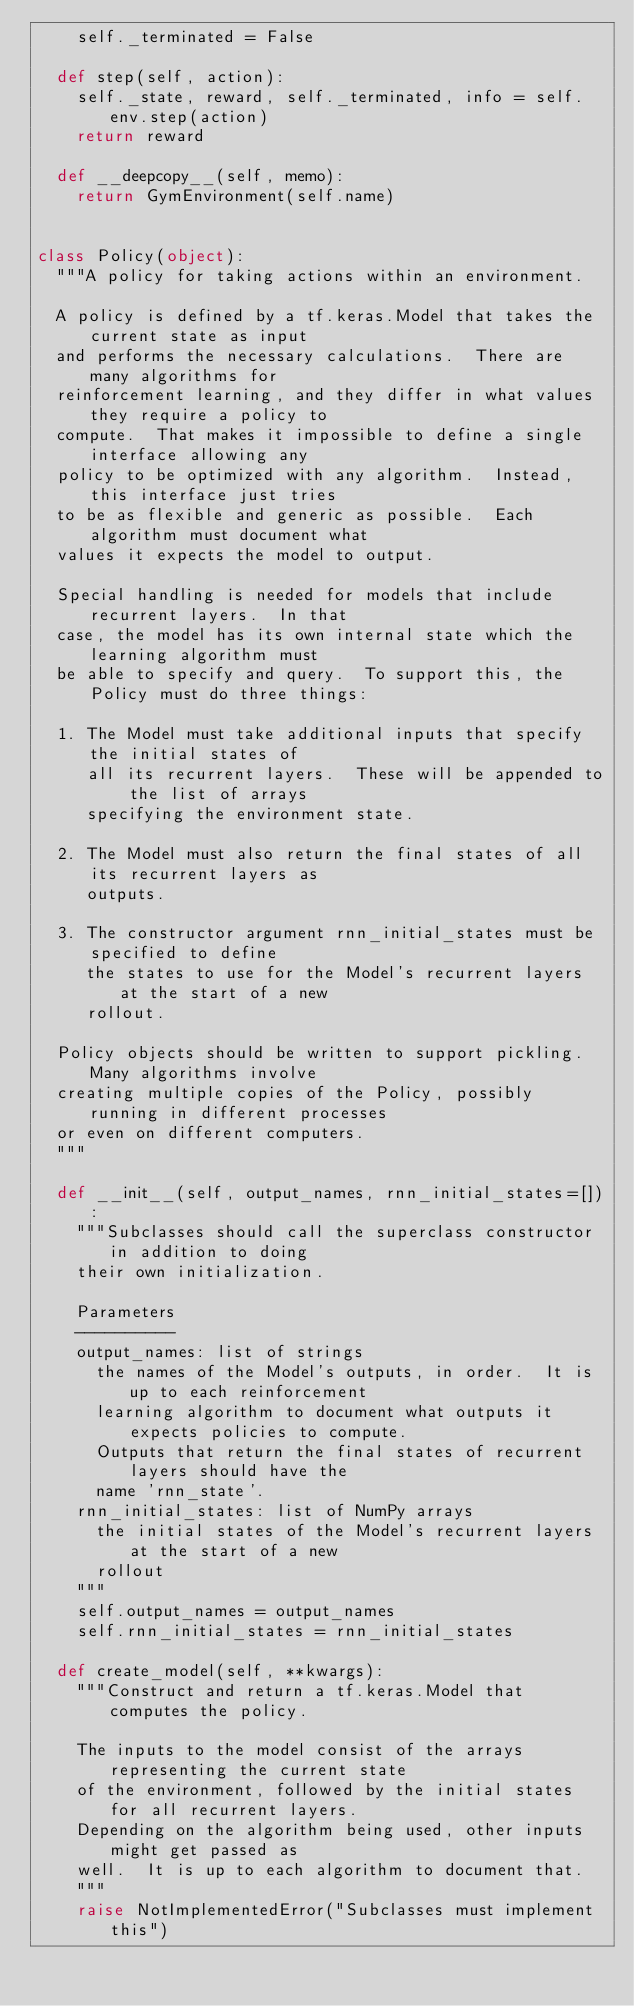Convert code to text. <code><loc_0><loc_0><loc_500><loc_500><_Python_>    self._terminated = False

  def step(self, action):
    self._state, reward, self._terminated, info = self.env.step(action)
    return reward

  def __deepcopy__(self, memo):
    return GymEnvironment(self.name)


class Policy(object):
  """A policy for taking actions within an environment.

  A policy is defined by a tf.keras.Model that takes the current state as input
  and performs the necessary calculations.  There are many algorithms for
  reinforcement learning, and they differ in what values they require a policy to
  compute.  That makes it impossible to define a single interface allowing any
  policy to be optimized with any algorithm.  Instead, this interface just tries
  to be as flexible and generic as possible.  Each algorithm must document what
  values it expects the model to output.

  Special handling is needed for models that include recurrent layers.  In that
  case, the model has its own internal state which the learning algorithm must
  be able to specify and query.  To support this, the Policy must do three things:

  1. The Model must take additional inputs that specify the initial states of
     all its recurrent layers.  These will be appended to the list of arrays
     specifying the environment state.

  2. The Model must also return the final states of all its recurrent layers as
     outputs.

  3. The constructor argument rnn_initial_states must be specified to define
     the states to use for the Model's recurrent layers at the start of a new
     rollout.

  Policy objects should be written to support pickling.  Many algorithms involve
  creating multiple copies of the Policy, possibly running in different processes
  or even on different computers.
  """

  def __init__(self, output_names, rnn_initial_states=[]):
    """Subclasses should call the superclass constructor in addition to doing
    their own initialization.

    Parameters
    ----------
    output_names: list of strings
      the names of the Model's outputs, in order.  It is up to each reinforcement
      learning algorithm to document what outputs it expects policies to compute.
      Outputs that return the final states of recurrent layers should have the
      name 'rnn_state'.
    rnn_initial_states: list of NumPy arrays
      the initial states of the Model's recurrent layers at the start of a new
      rollout
    """
    self.output_names = output_names
    self.rnn_initial_states = rnn_initial_states

  def create_model(self, **kwargs):
    """Construct and return a tf.keras.Model that computes the policy.

    The inputs to the model consist of the arrays representing the current state
    of the environment, followed by the initial states for all recurrent layers.
    Depending on the algorithm being used, other inputs might get passed as
    well.  It is up to each algorithm to document that.
    """
    raise NotImplementedError("Subclasses must implement this")
</code> 